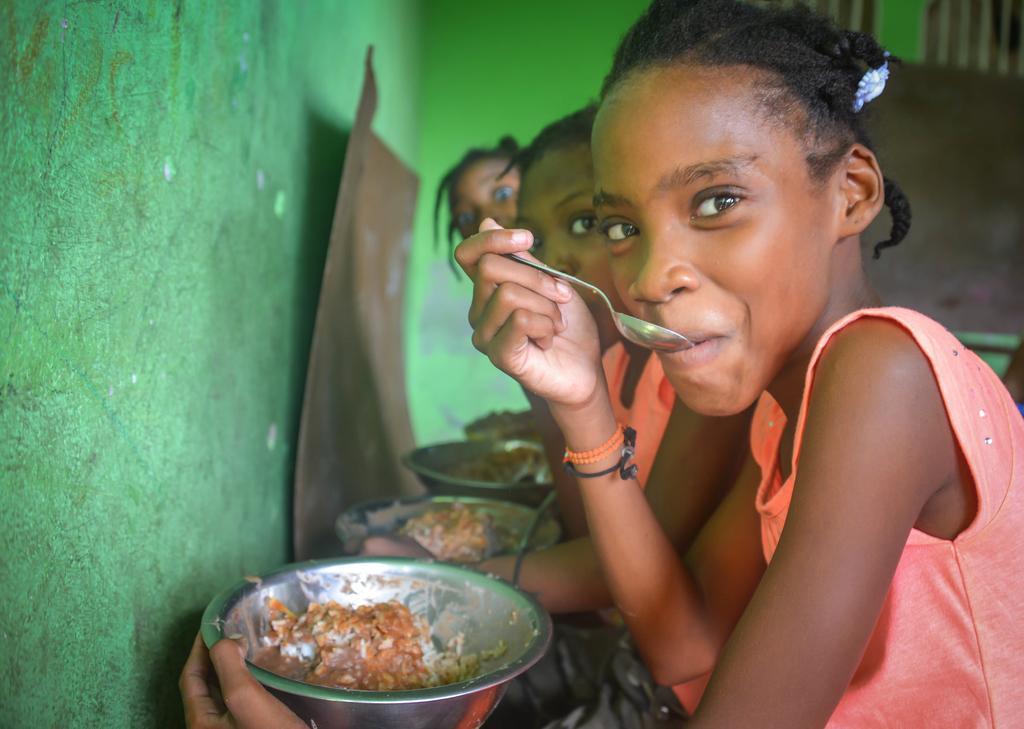Describe this image in one or two sentences. In this image there are three girls who are sitting one beside the other is eating the food with the spoons. In front of them there is a steel bowl in which there is some food. In front of them there is a green colour wall. 